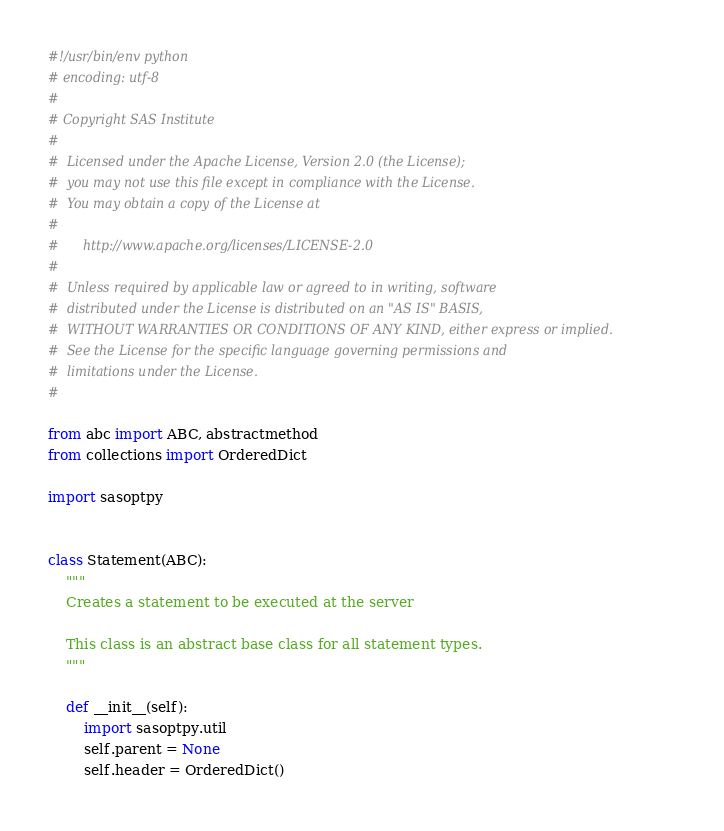Convert code to text. <code><loc_0><loc_0><loc_500><loc_500><_Python_>#!/usr/bin/env python
# encoding: utf-8
#
# Copyright SAS Institute
#
#  Licensed under the Apache License, Version 2.0 (the License);
#  you may not use this file except in compliance with the License.
#  You may obtain a copy of the License at
#
#      http://www.apache.org/licenses/LICENSE-2.0
#
#  Unless required by applicable law or agreed to in writing, software
#  distributed under the License is distributed on an "AS IS" BASIS,
#  WITHOUT WARRANTIES OR CONDITIONS OF ANY KIND, either express or implied.
#  See the License for the specific language governing permissions and
#  limitations under the License.
#

from abc import ABC, abstractmethod
from collections import OrderedDict

import sasoptpy


class Statement(ABC):
    """
    Creates a statement to be executed at the server

    This class is an abstract base class for all statement types.
    """

    def __init__(self):
        import sasoptpy.util
        self.parent = None
        self.header = OrderedDict()</code> 